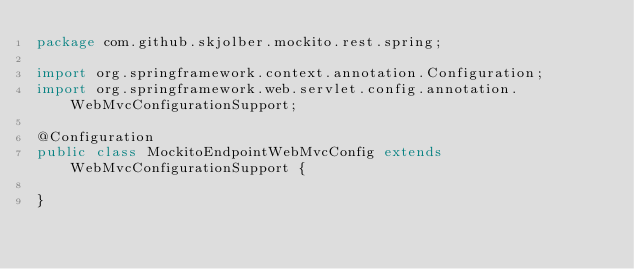Convert code to text. <code><loc_0><loc_0><loc_500><loc_500><_Java_>package com.github.skjolber.mockito.rest.spring;

import org.springframework.context.annotation.Configuration;
import org.springframework.web.servlet.config.annotation.WebMvcConfigurationSupport;

@Configuration
public class MockitoEndpointWebMvcConfig extends WebMvcConfigurationSupport {

}
</code> 